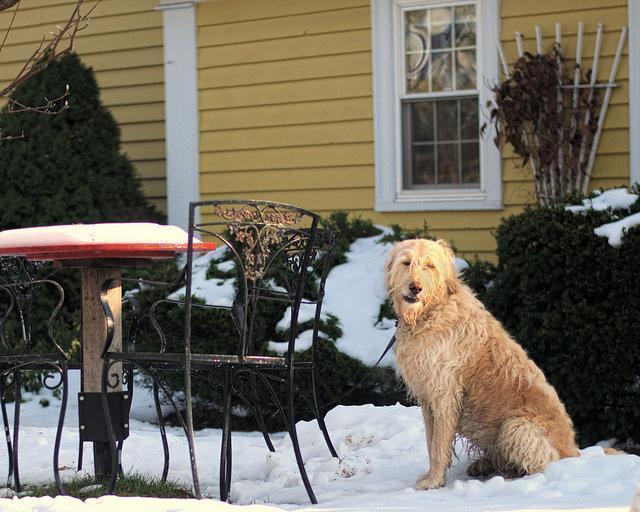What famous animal does this one most closely resemble?
Select the accurate answer and provide justification: `Answer: choice
Rationale: srationale.`
Options: Dumbo, garfield, free willy, benji. Answer: benji.
Rationale: The dog in the snow is very similar to the dog in the movie benji. 